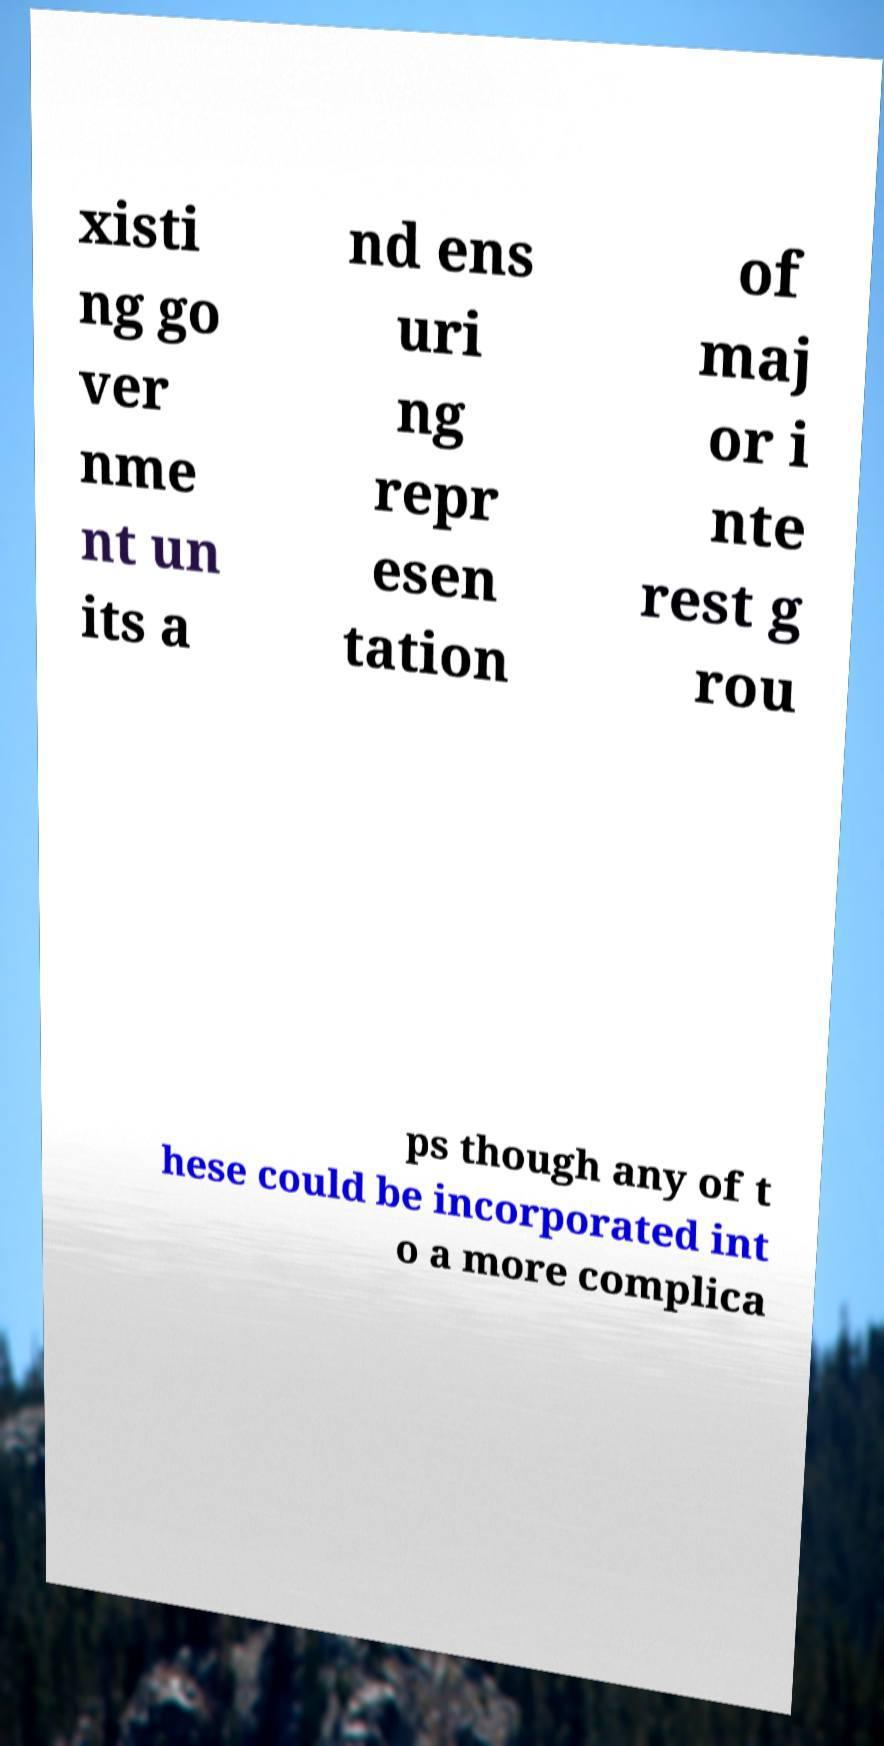Please read and relay the text visible in this image. What does it say? xisti ng go ver nme nt un its a nd ens uri ng repr esen tation of maj or i nte rest g rou ps though any of t hese could be incorporated int o a more complica 